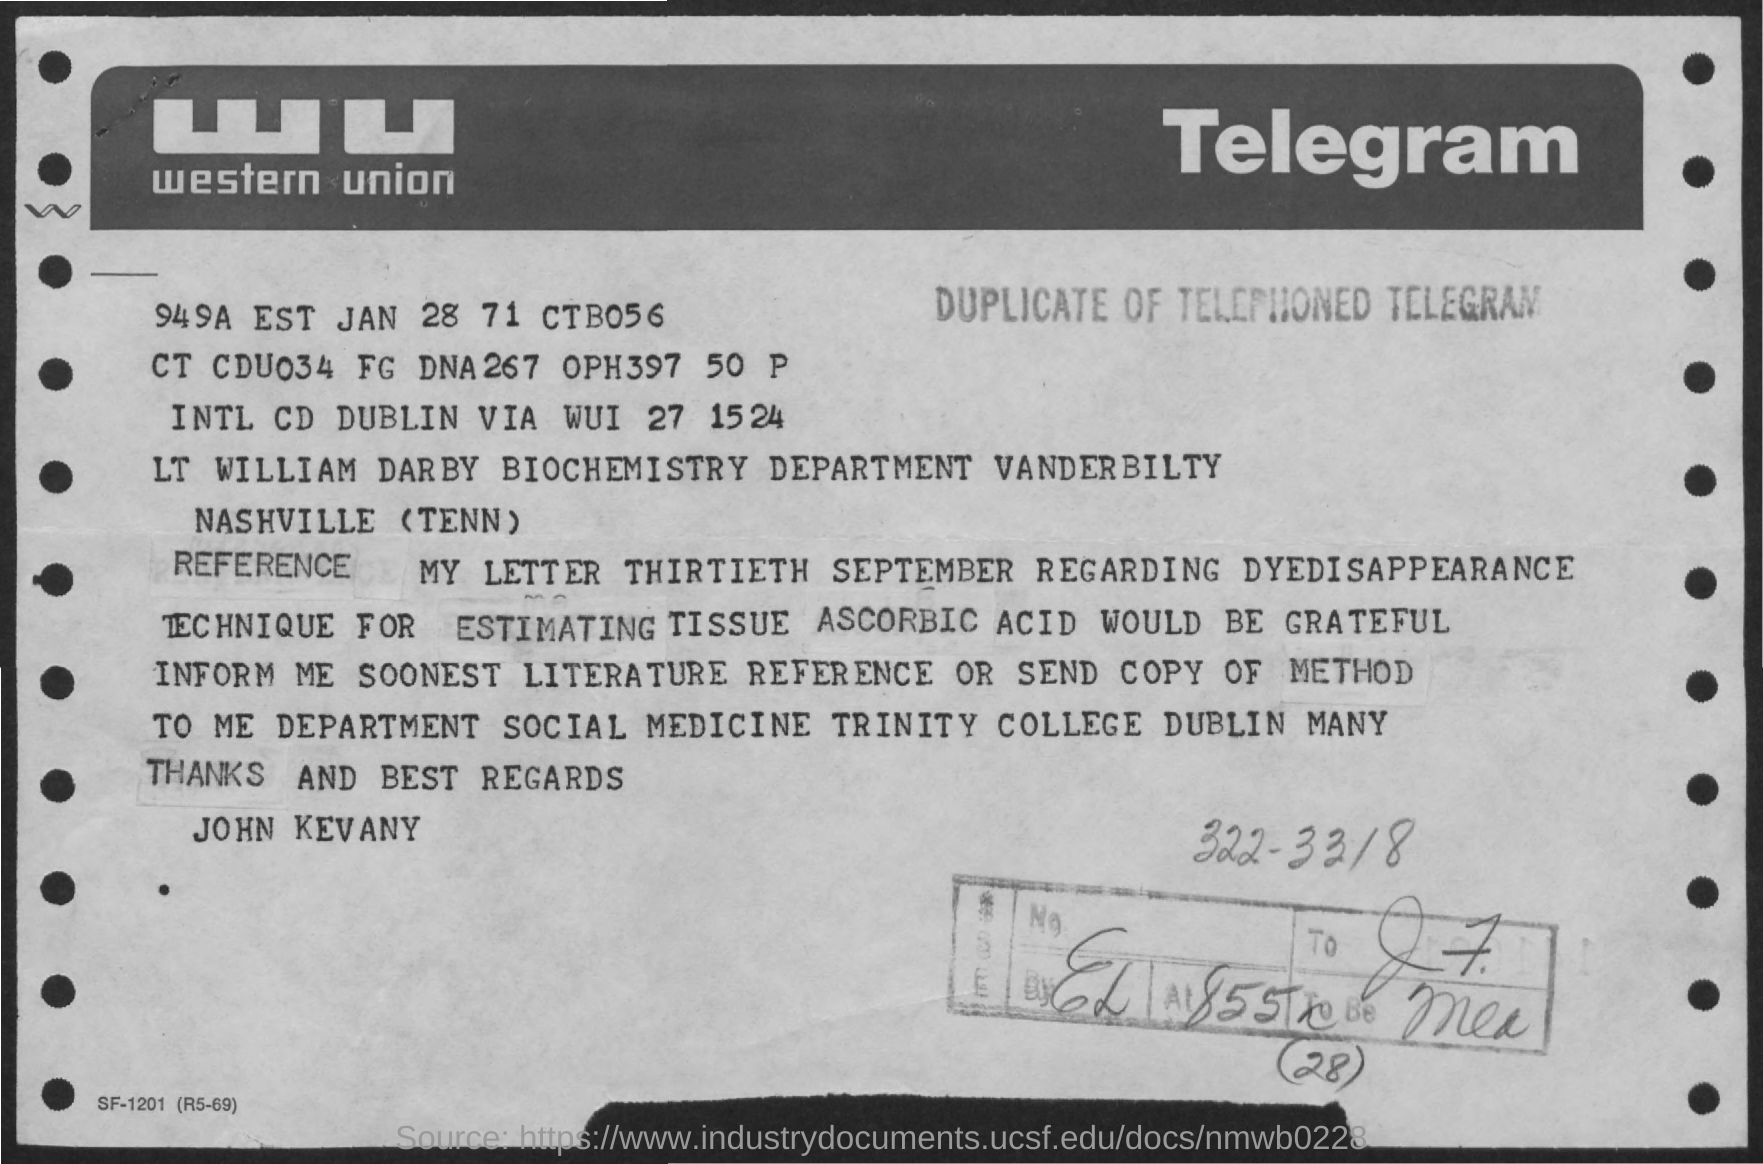Draw attention to some important aspects in this diagram. The sender is John Kevany. The telegram company name is Western Union. 